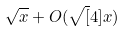<formula> <loc_0><loc_0><loc_500><loc_500>\sqrt { x } + O ( \sqrt { [ } 4 ] { x } )</formula> 